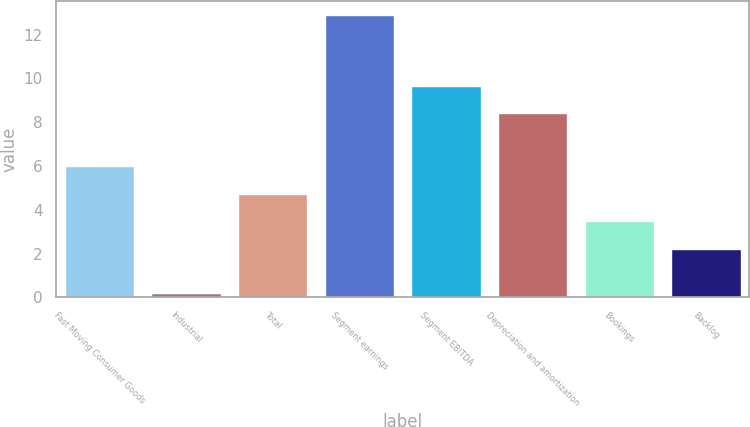Convert chart to OTSL. <chart><loc_0><loc_0><loc_500><loc_500><bar_chart><fcel>Fast Moving Consumer Goods<fcel>Industrial<fcel>Total<fcel>Segment earnings<fcel>Segment EBITDA<fcel>Depreciation and amortization<fcel>Bookings<fcel>Backlog<nl><fcel>6.01<fcel>0.2<fcel>4.74<fcel>12.9<fcel>9.67<fcel>8.4<fcel>3.47<fcel>2.2<nl></chart> 